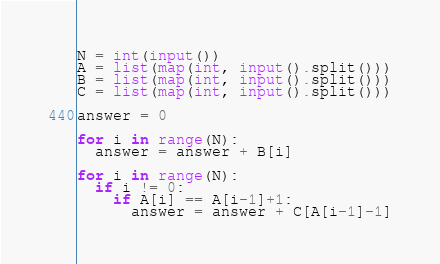<code> <loc_0><loc_0><loc_500><loc_500><_Python_>N = int(input())
A = list(map(int, input().split()))
B = list(map(int, input().split()))
C = list(map(int, input().split()))
 
answer = 0
 
for i in range(N):
  answer = answer + B[i]
  
for i in range(N):
  if i != 0:
    if A[i] == A[i-1]+1:
      answer = answer + C[A[i-1]-1]</code> 